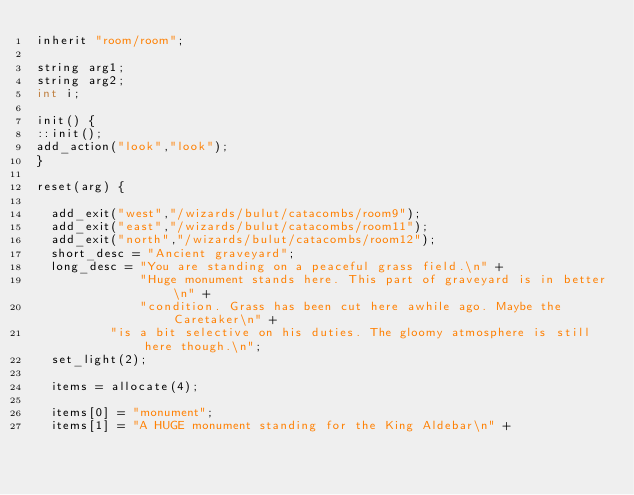Convert code to text. <code><loc_0><loc_0><loc_500><loc_500><_C_>inherit "room/room";

string arg1;
string arg2;
int i;

init() {
::init();
add_action("look","look");
}

reset(arg) {

  add_exit("west","/wizards/bulut/catacombs/room9");
  add_exit("east","/wizards/bulut/catacombs/room11");
  add_exit("north","/wizards/bulut/catacombs/room12");
  short_desc = "Ancient graveyard";
  long_desc = "You are standing on a peaceful grass field.\n" +
              "Huge monument stands here. This part of graveyard is in better\n" + 
              "condition. Grass has been cut here awhile ago. Maybe the Caretaker\n" +
	      "is a bit selective on his duties. The gloomy atmosphere is still here though.\n";
  set_light(2);                 

  items = allocate(4);

  items[0] = "monument";
  items[1] = "A HUGE monument standing for the King Aldebar\n" +</code> 